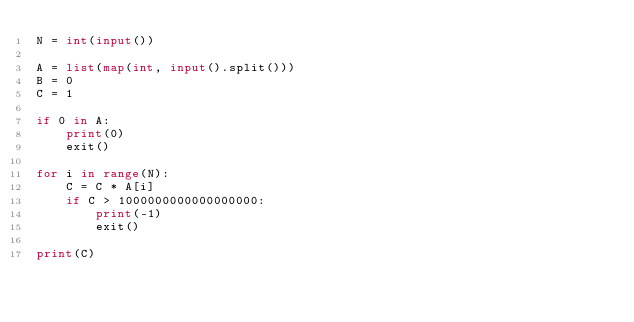<code> <loc_0><loc_0><loc_500><loc_500><_Python_>N = int(input())

A = list(map(int, input().split()))
B = 0
C = 1

if 0 in A:
    print(0)
    exit()

for i in range(N):
    C = C * A[i]
    if C > 1000000000000000000:
        print(-1)
        exit()

print(C)</code> 